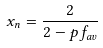Convert formula to latex. <formula><loc_0><loc_0><loc_500><loc_500>x _ { n } = \frac { 2 } { 2 - p f _ { a v } }</formula> 